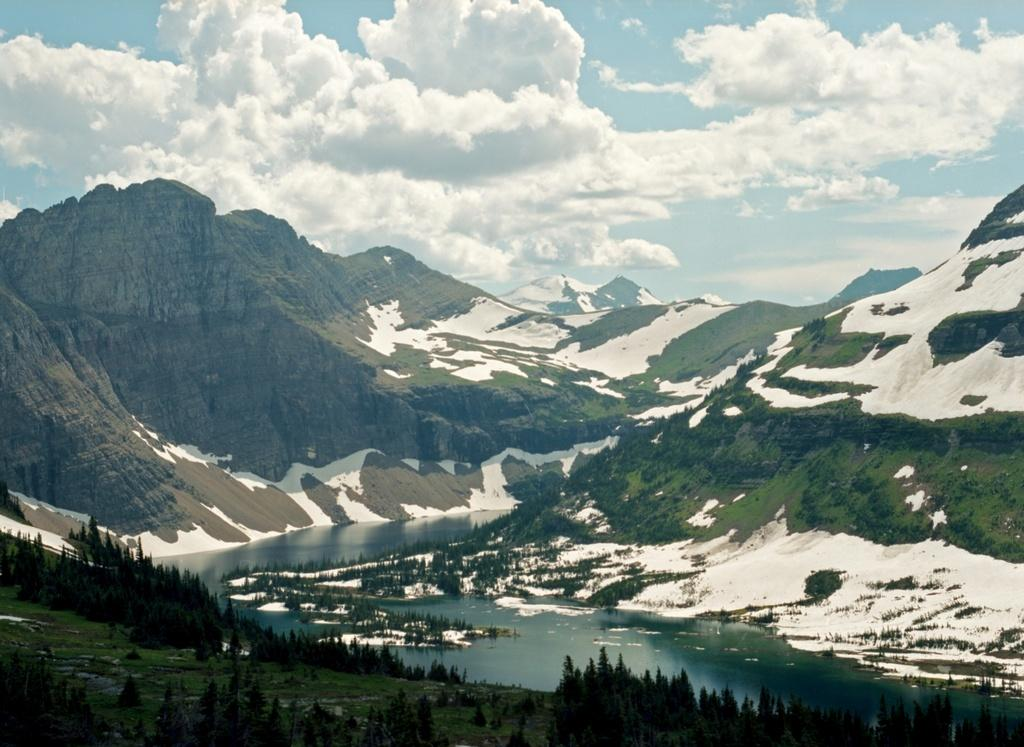What type of landscape is depicted in the image? The image features mountains, hills, and trees. Is there any snow visible in the image? Yes, there is snow in the image. What can be seen at the bottom of the image? There is water visible at the bottom of the image. How would you describe the sky in the background? The sky in the background is cloudy. What type of society is depicted in the image? The image does not depict a society; it features a natural landscape with mountains, hills, trees, snow, water, and a cloudy sky. 